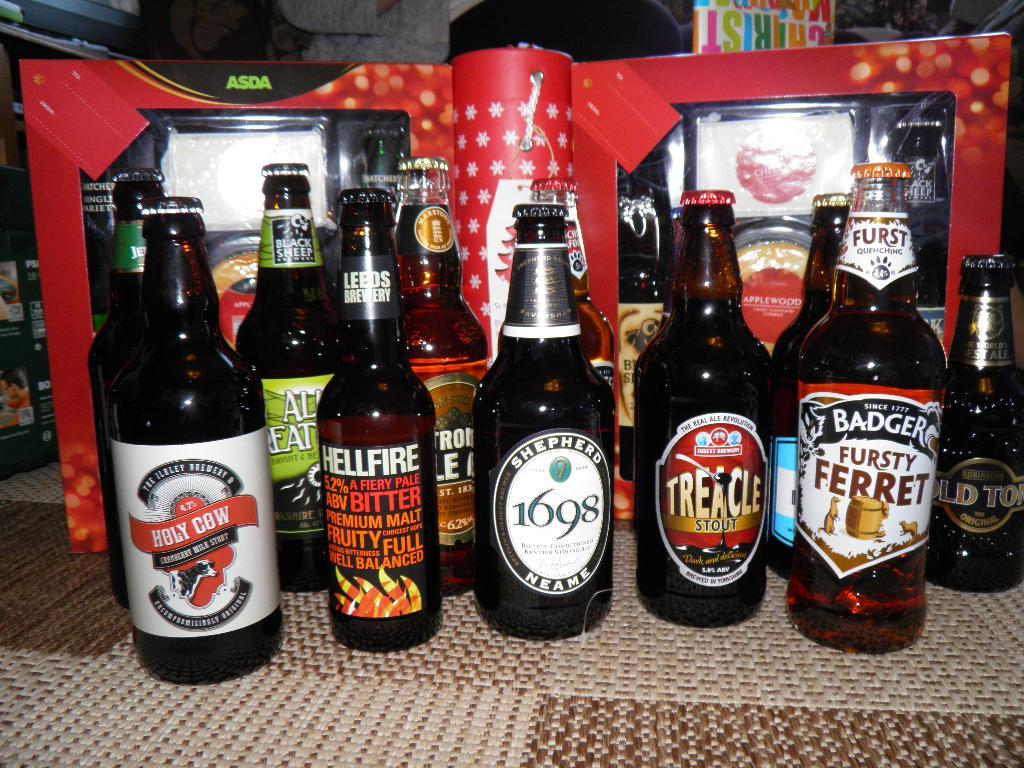<image>
Create a compact narrative representing the image presented. A line of bottles including Fursty Ferret and 1698 brands. 